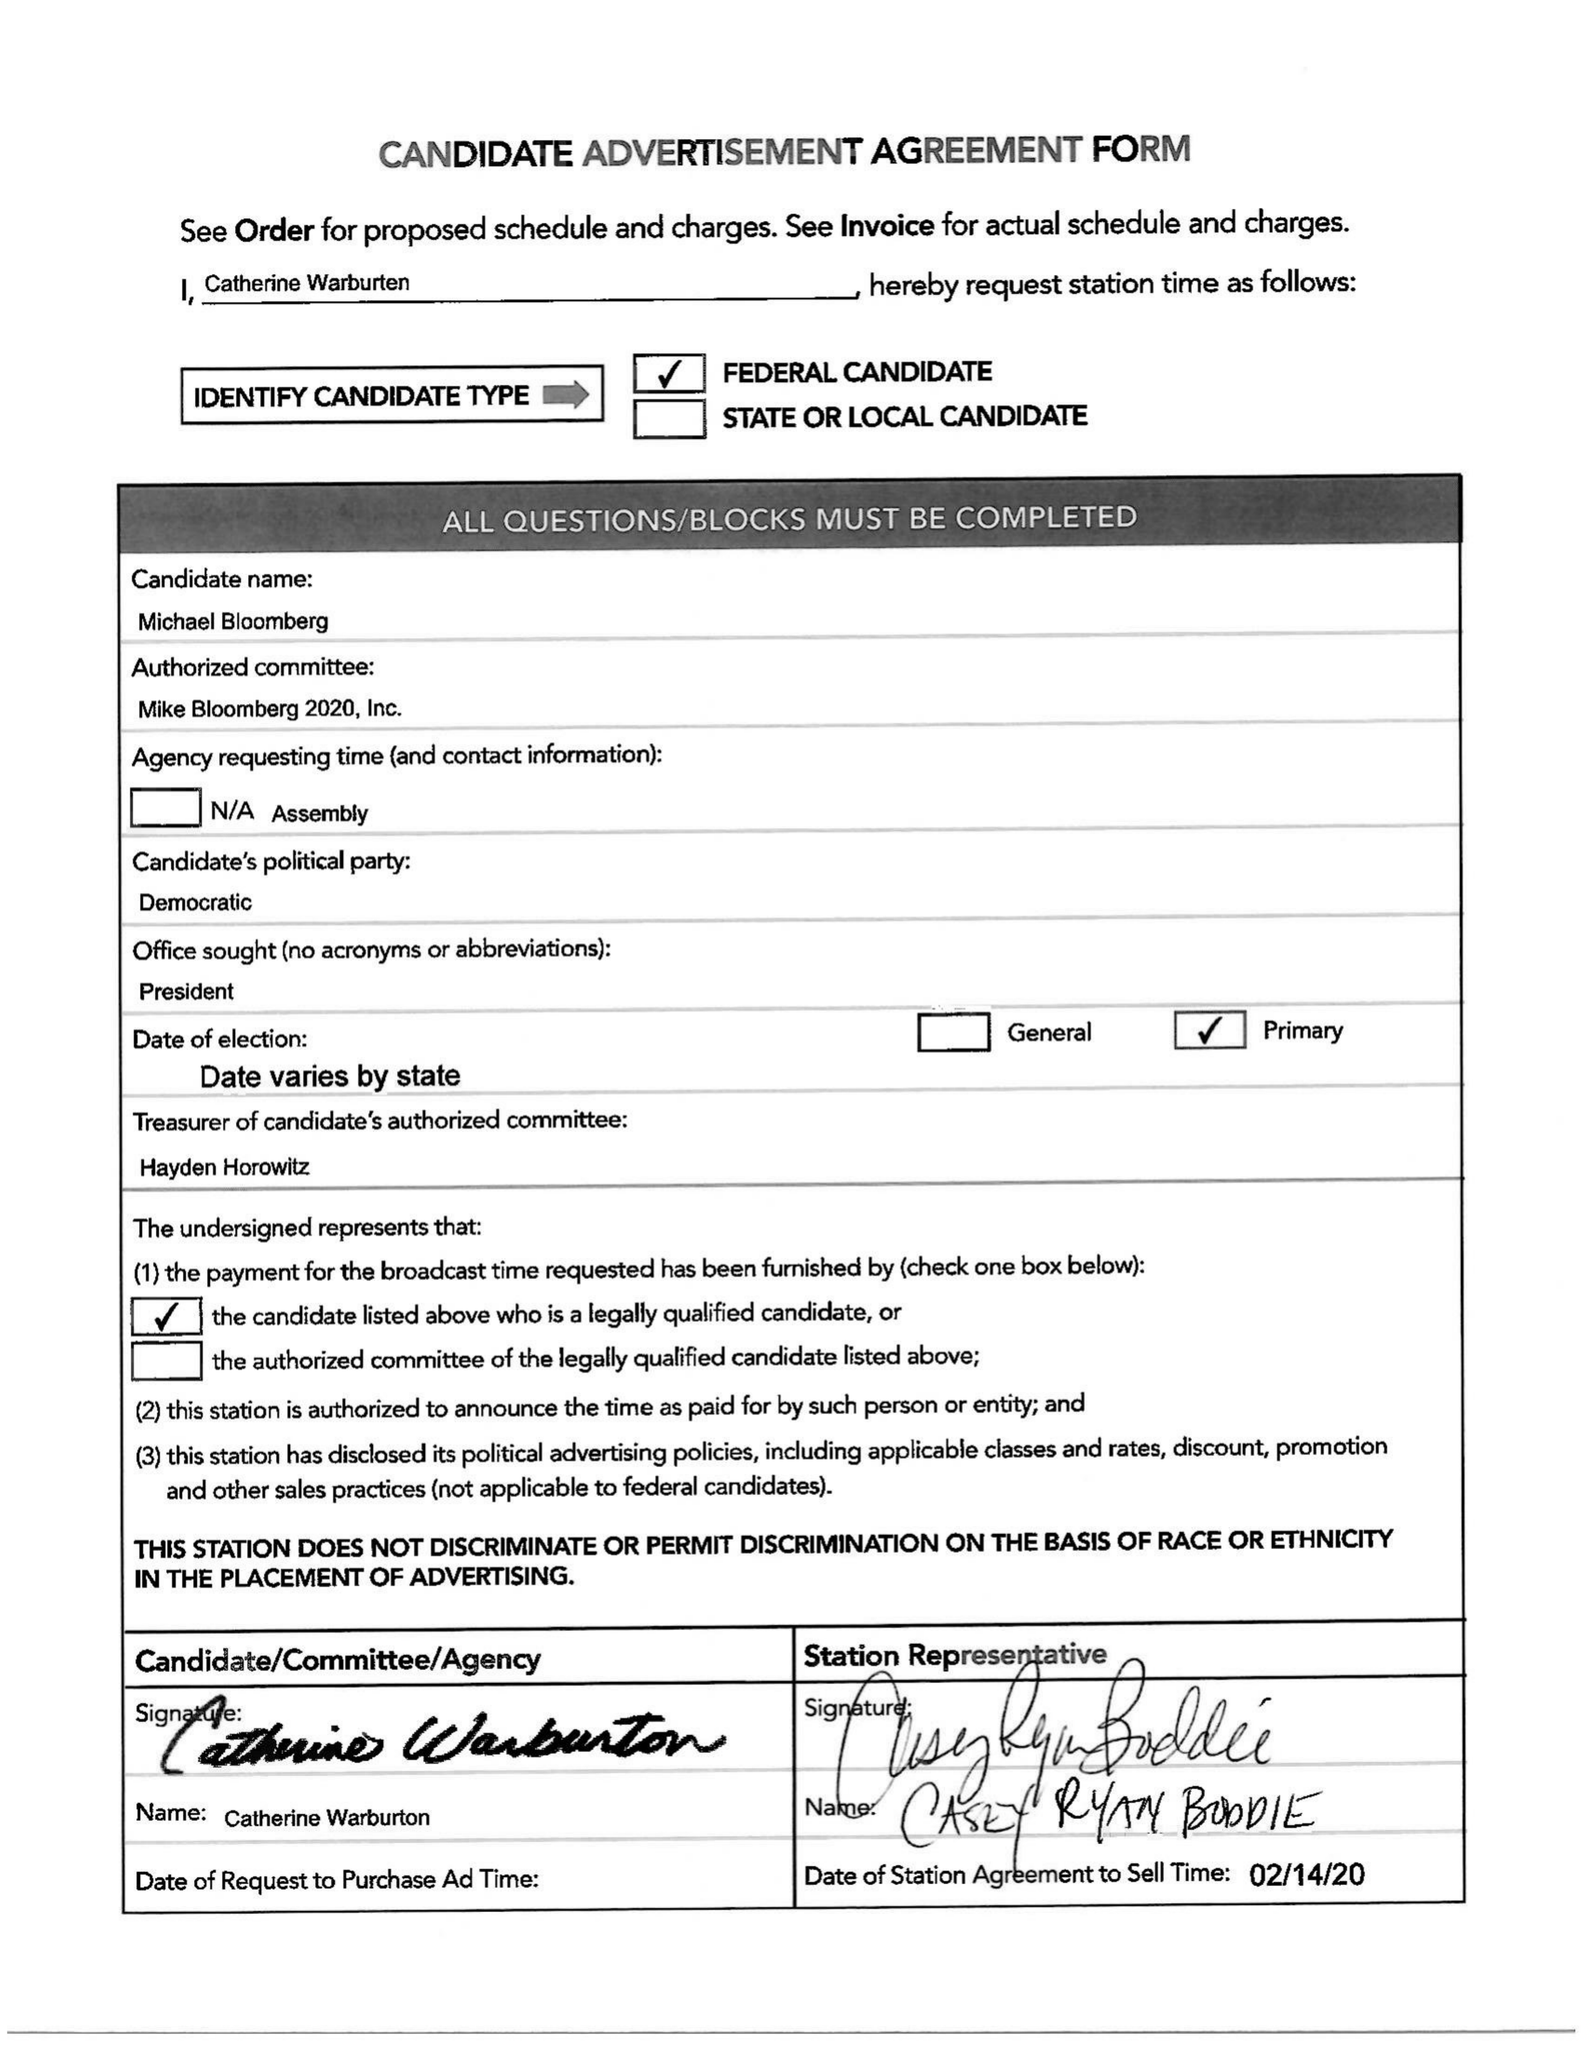What is the value for the gross_amount?
Answer the question using a single word or phrase. None 